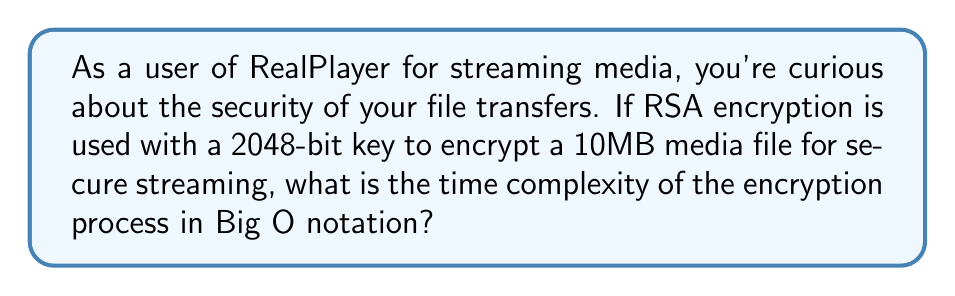Help me with this question. Let's break this down step-by-step:

1. RSA encryption involves raising a message to a power modulo n, where n is the product of two large primes.

2. The time complexity of RSA encryption is primarily determined by the modular exponentiation operation.

3. For a k-bit key (in this case, k = 2048), the modular exponentiation can be performed using the square-and-multiply algorithm.

4. The square-and-multiply algorithm has a time complexity of $O(k^3)$ for each block of data being encrypted.

5. However, we need to consider the size of the file being encrypted. A 10MB file is approximately $10 * 2^{20}$ bits.

6. RSA typically encrypts data in blocks. Let's assume a block size of 2048 bits (to match the key size).

7. The number of blocks to be encrypted is:
   $\frac{10 * 2^{20}}{2048} = 5120$ blocks

8. For each block, we perform the $O(k^3)$ operation.

9. Therefore, the total time complexity is:
   $O(5120 * k^3) = O(k^3)$

10. The constant factor (5120) is dropped in Big O notation.

11. Thus, the time complexity remains $O(k^3)$, where k is the key size in bits.
Answer: $O(k^3)$ 